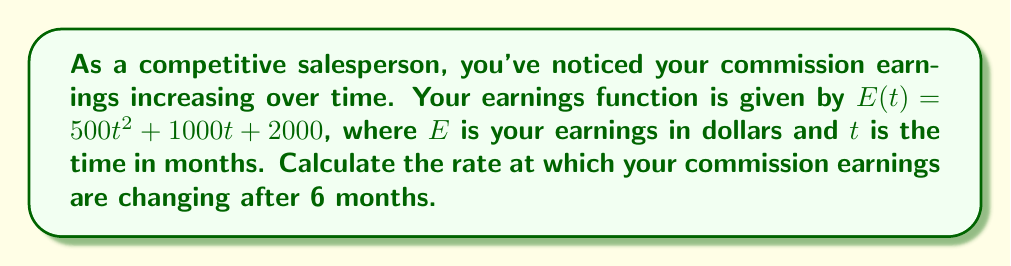Help me with this question. To find the rate of change in commission earnings, we need to calculate the derivative of the earnings function and evaluate it at $t = 6$ months.

Step 1: Identify the earnings function
$E(t) = 500t^2 + 1000t + 2000$

Step 2: Calculate the derivative of $E(t)$
$$\frac{dE}{dt} = \frac{d}{dt}(500t^2 + 1000t + 2000)$$
$$\frac{dE}{dt} = 1000t + 1000$$

Step 3: Evaluate the derivative at $t = 6$ months
$$\frac{dE}{dt}\bigg|_{t=6} = 1000(6) + 1000$$
$$\frac{dE}{dt}\bigg|_{t=6} = 6000 + 1000 = 7000$$

The rate of change in commission earnings after 6 months is $7000 dollars per month.
Answer: $7000 \text{ dollars per month}$ 